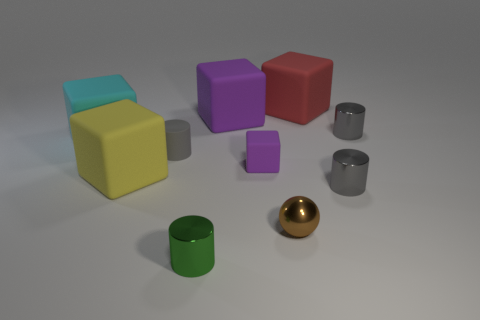There is a gray cylinder that is behind the large cyan matte block; is there a gray rubber cylinder to the right of it?
Your answer should be compact. No. How many small things are either red metallic things or gray cylinders?
Make the answer very short. 3. Is there a purple rubber ball that has the same size as the gray rubber object?
Keep it short and to the point. No. What number of metal objects are brown things or small objects?
Offer a terse response. 4. What number of large cyan rubber cubes are there?
Give a very brief answer. 1. Are the tiny gray cylinder that is on the left side of the small green cylinder and the purple cube behind the small gray rubber object made of the same material?
Make the answer very short. Yes. What is the size of the gray cylinder that is the same material as the red object?
Offer a very short reply. Small. The big matte thing right of the brown metal sphere has what shape?
Provide a short and direct response. Cube. There is a big block that is left of the yellow rubber thing; is it the same color as the tiny cylinder that is on the left side of the small green cylinder?
Provide a succinct answer. No. There is a thing that is the same color as the tiny block; what is its size?
Ensure brevity in your answer.  Large. 